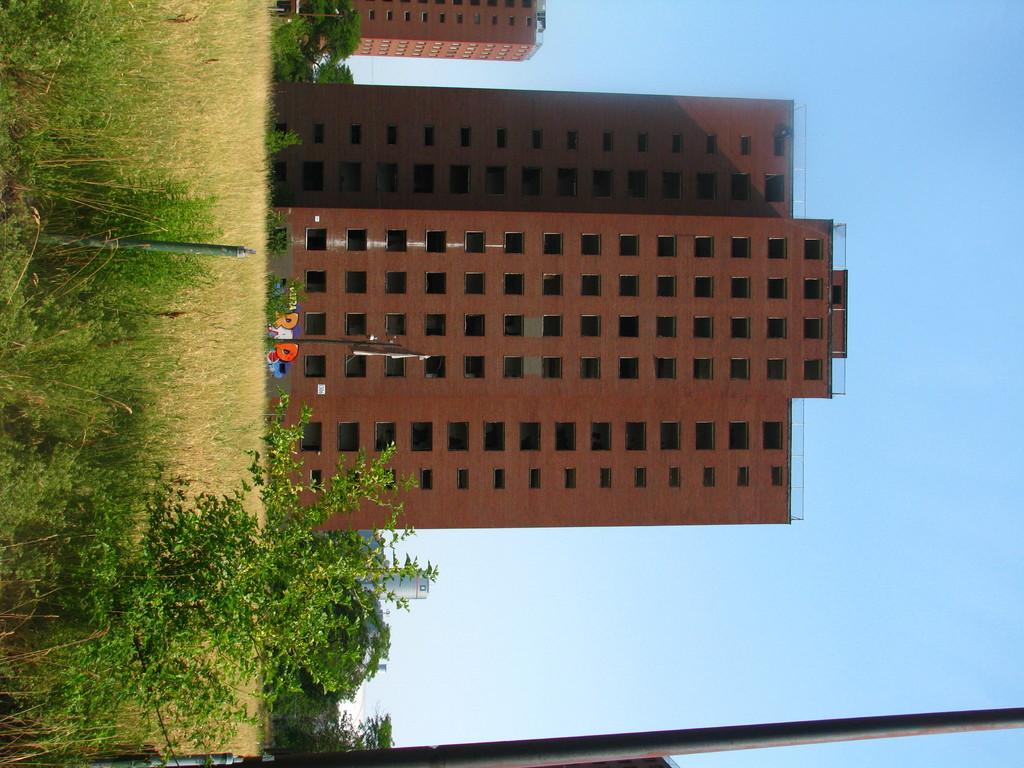What is located in the center of the image? There are buildings in the center of the image. What can be seen at the bottom of the image? There is a pole at the bottom of the image. What type of vegetation is on the left side of the image? There is grass and plants on the left side of the image. What is visible on the right side of the image? The sky is visible on the right side of the image. How many babies are present in the image? There are no babies present in the image. Can you tell me what type of lawyer is depicted in the image? There is no lawyer depicted in the image. 